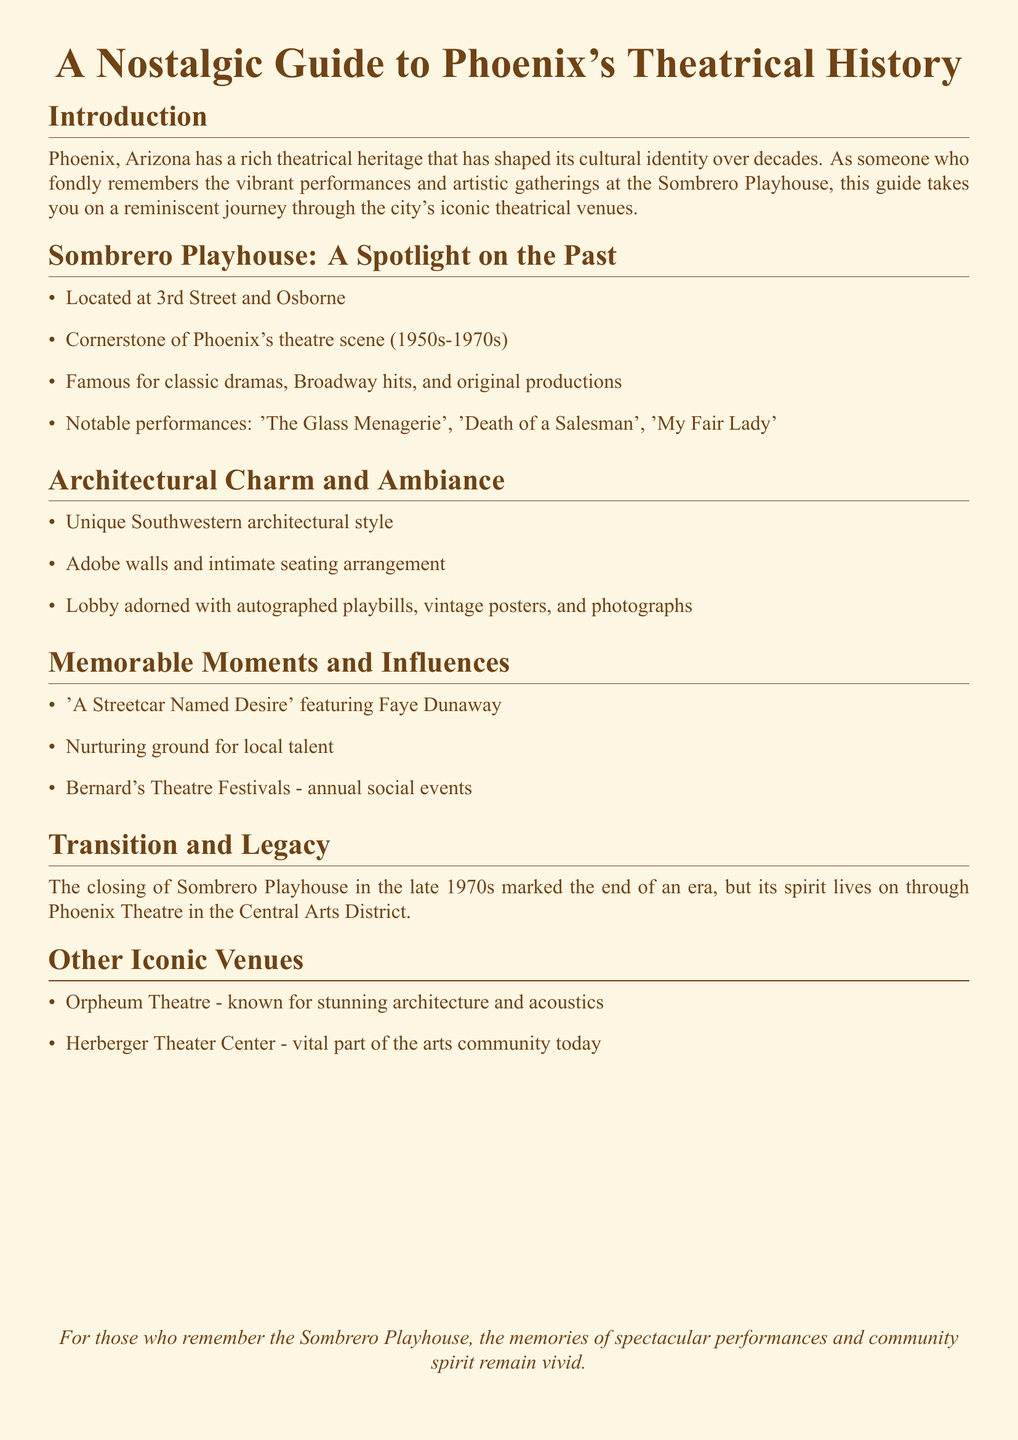What is the location of Sombrero Playhouse? The address of Sombrero Playhouse is mentioned in the document as 3rd Street and Osborne.
Answer: 3rd Street and Osborne During which decades was Sombrero Playhouse a cornerstone of Phoenix's theatre scene? The document specifies the decades during which Sombrero Playhouse was significant, which are the 1950s to the 1970s.
Answer: 1950s-1970s Which notable performance featured Faye Dunaway? The document references a specific performance that included Faye Dunaway.
Answer: A Streetcar Named Desire What unique architectural feature is mentioned about Sombrero Playhouse? The document highlights the specific architectural style of Sombrero Playhouse, noted as Southwestern.
Answer: Southwestern What is the current venue that carries on the spirit of Sombrero Playhouse? The document mentions another venue that continues the legacy of Sombrero Playhouse.
Answer: Phoenix Theatre How were the lobby decorations described? The document describes what adorns the lobby of Sombrero Playhouse.
Answer: Autographed playbills, vintage posters, and photographs What was a major annual event associated with Sombrero Playhouse? A specific annual event is noted in the document that involved Sombrero Playhouse.
Answer: Bernard's Theatre Festivals Which two other iconic venues are mentioned in the guide? The document lists two other important venues in Phoenix's theatrical history.
Answer: Orpheum Theatre, Herberger Theater Center 